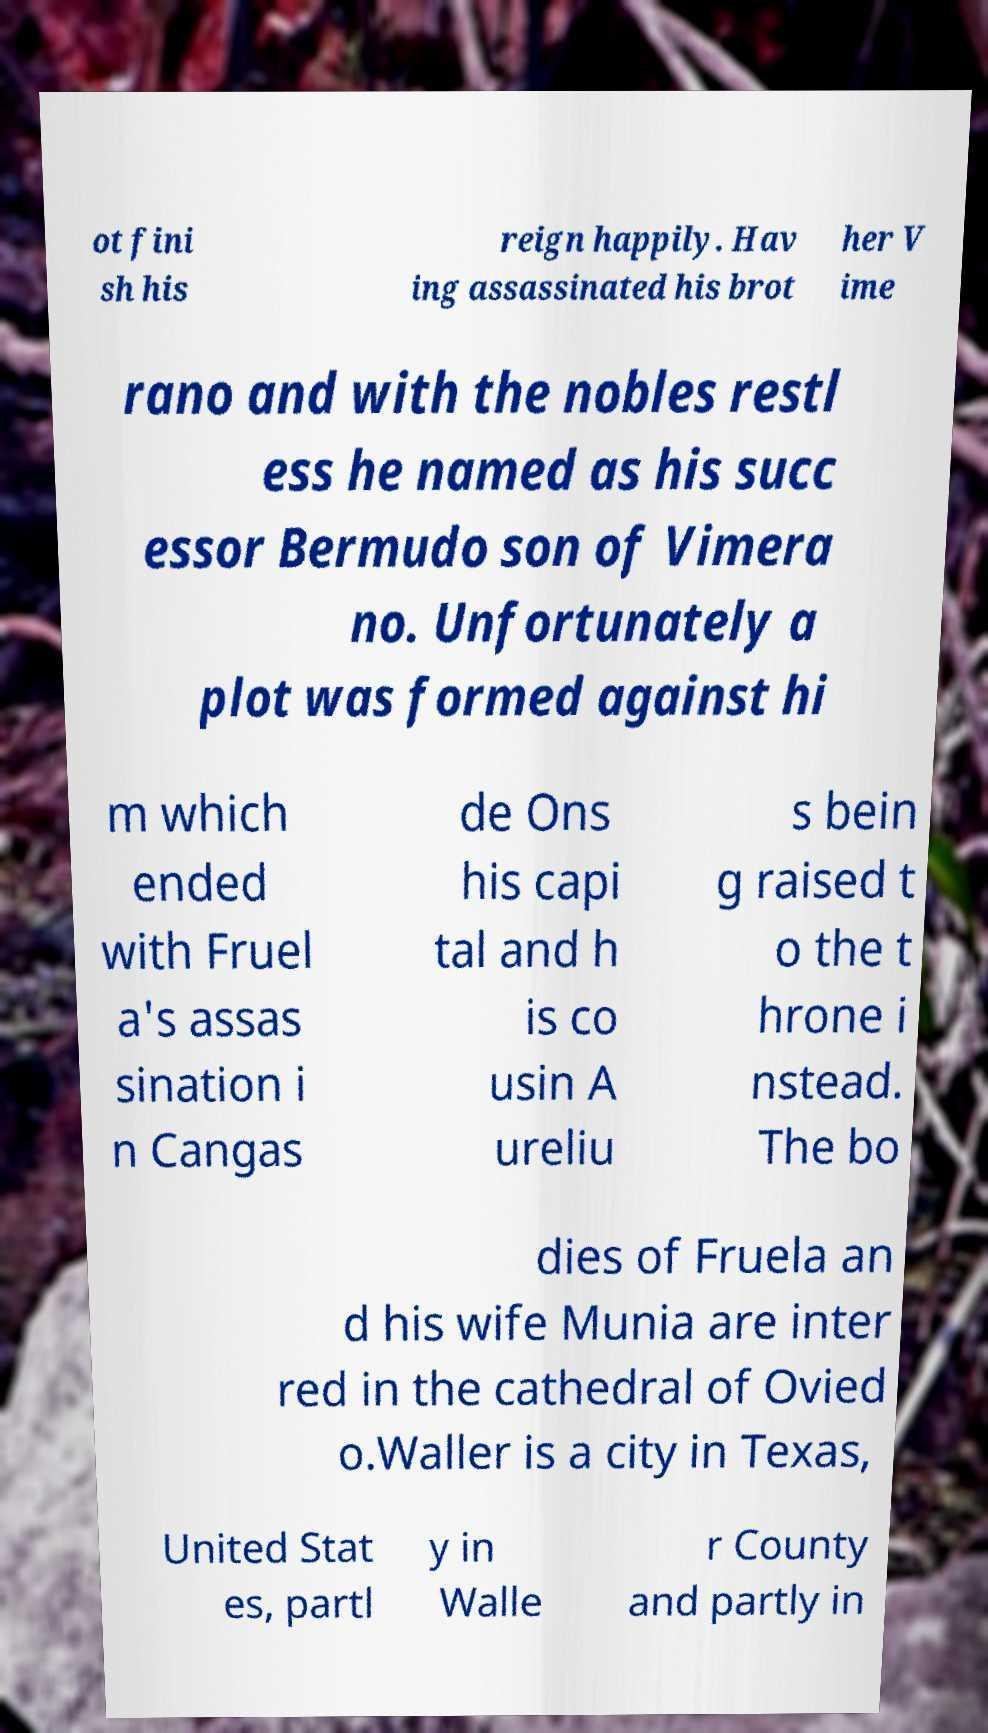I need the written content from this picture converted into text. Can you do that? ot fini sh his reign happily. Hav ing assassinated his brot her V ime rano and with the nobles restl ess he named as his succ essor Bermudo son of Vimera no. Unfortunately a plot was formed against hi m which ended with Fruel a's assas sination i n Cangas de Ons his capi tal and h is co usin A ureliu s bein g raised t o the t hrone i nstead. The bo dies of Fruela an d his wife Munia are inter red in the cathedral of Ovied o.Waller is a city in Texas, United Stat es, partl y in Walle r County and partly in 